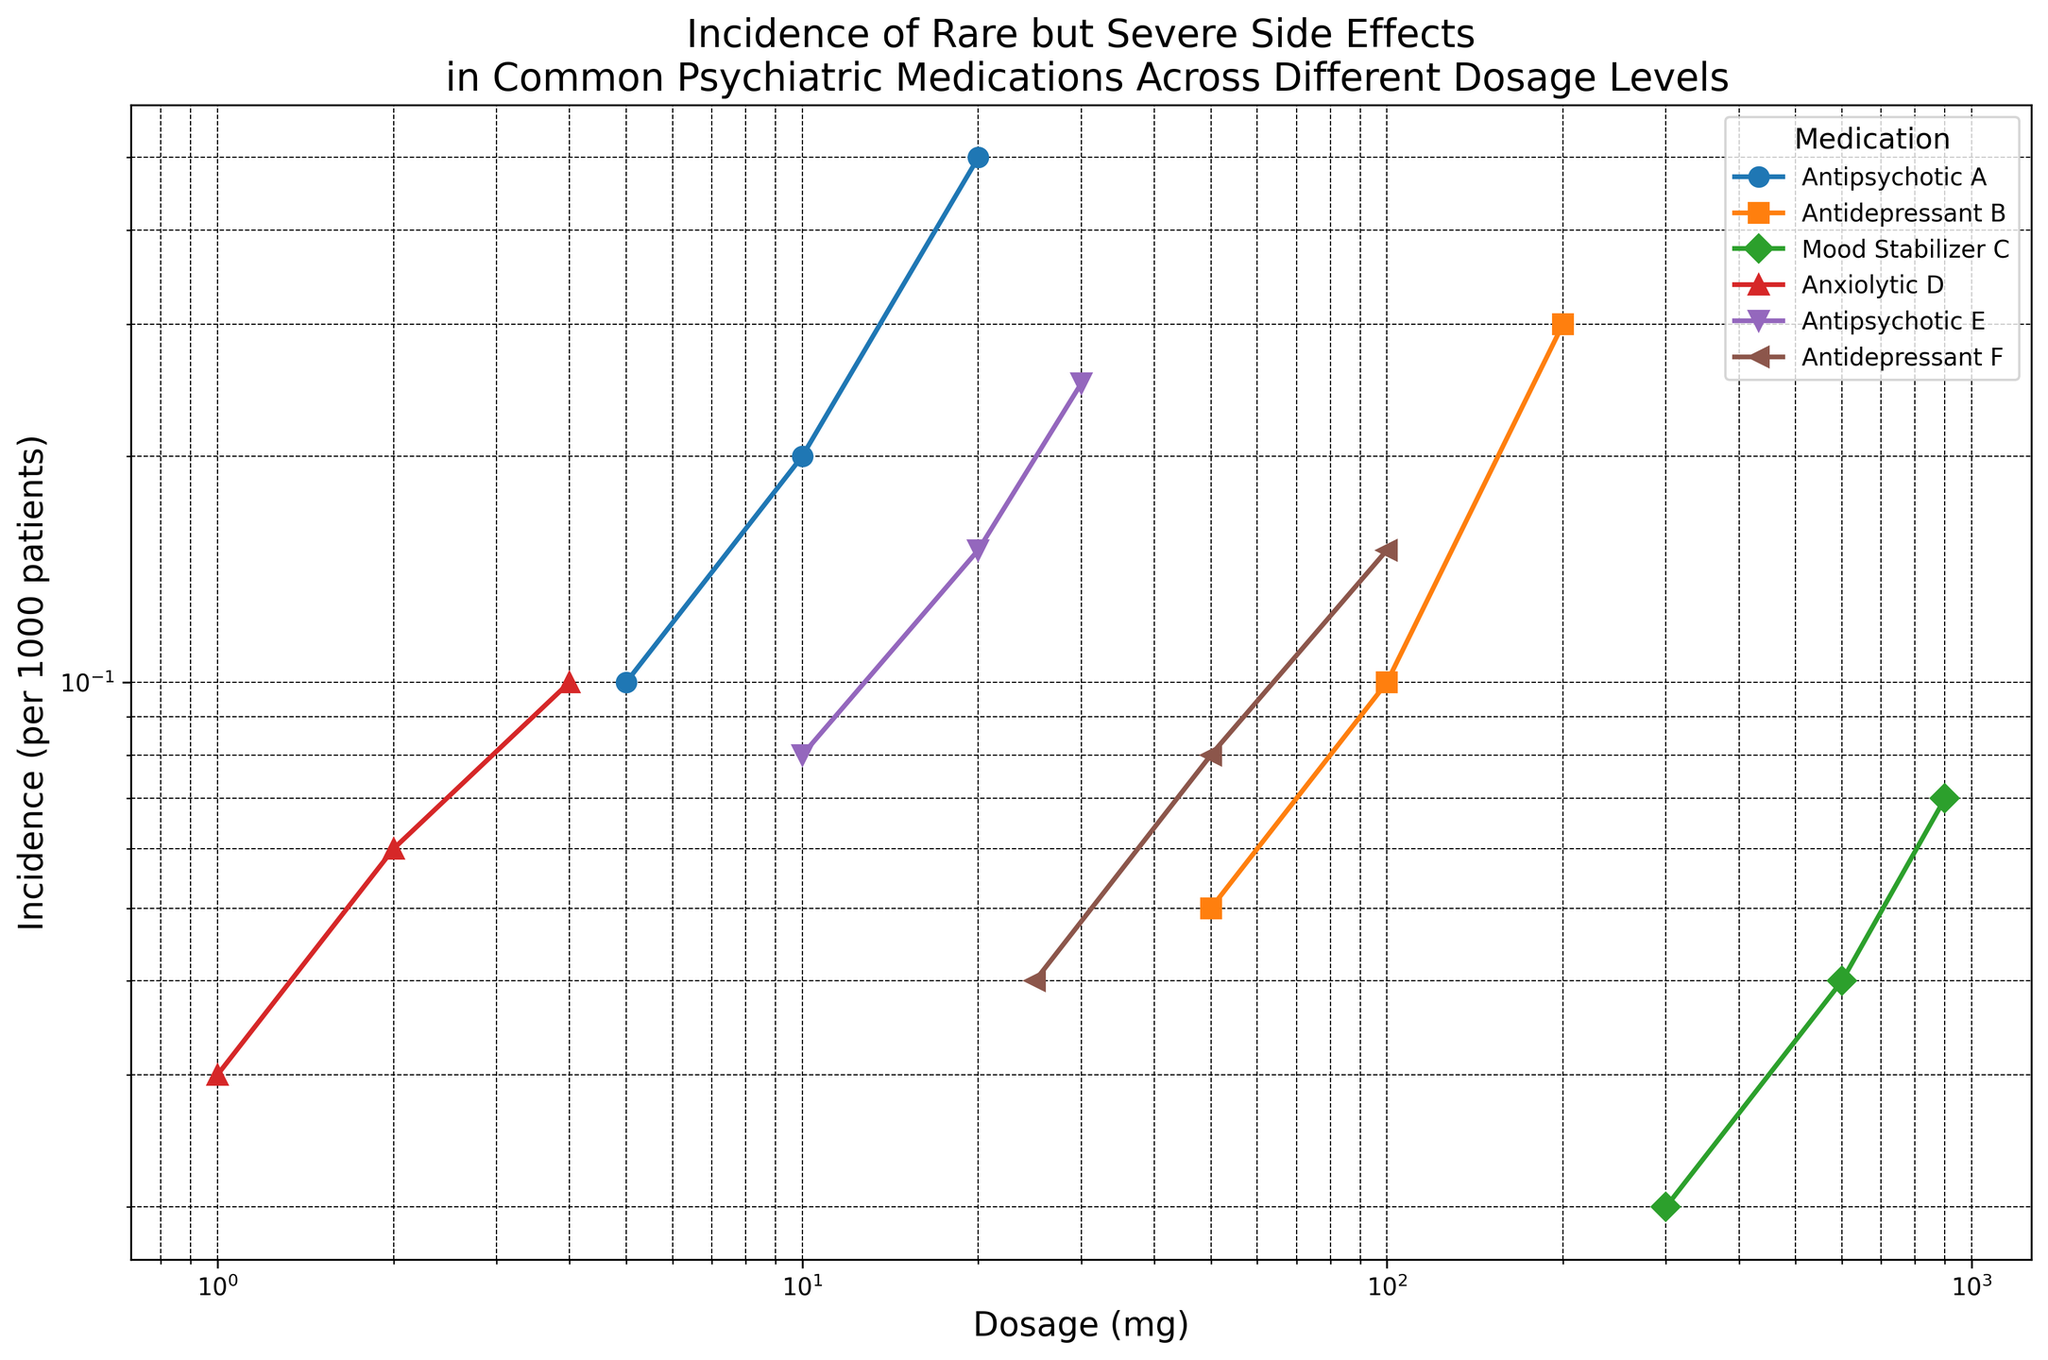What is the incidence of Agranulocytosis for Antipsychotic E at a dosage of 20 mg? First, identify the line and marker color for Antipsychotic E. Then, locate the dosage of 20 mg on the x-axis and follow it up to the corresponding point. Finally, read the incidence from the y-axis.
Answer: 0.15 Between Antipsychotic A at 20 mg and Antidepressant B at 200 mg, which has a higher incidence of severe side effects? Firstly, find the incidences of both Antipsychotic A at 20 mg and Antidepressant B at 200 mg by following the respective lines. Compare the values: 0.5 for Antipsychotic A, and 0.3 for Antidepressant B.
Answer: Antipsychotic A Which medication shows a consistent linear increase in incidence on a log-log scale? Observe the lines for all medications. A consistent linear increase on a log-log scale indicates an exponential relationship between dosage and incidence. Identify which line maintains a straight path upwards.
Answer: Antipsychotic A What is the comparison in incidence rates between the lowest dosage of Antipsychotic A and the highest dosage of Antidepressant F? Find the incidence rates for Antipsychotic A at 5 mg and Antidepressant F at 100 mg. Compare the values: Antipsychotic A at 5 mg (0.1) and Antidepressant F at 100 mg (0.15).
Answer: Antidepressant F is higher What is the median incidence rate for Mood Stabilizer C across all dosages? Find the incidence rates for all dosages of Mood Stabilizer C: 0.02 (300 mg), 0.04 (600 mg), and 0.07 (900 mg). Sort them: 0.02, 0.04, 0.07. The median is the middle value.
Answer: 0.04 What trend is observed for Anxiolytic D regarding its incidence rate as the dosage increases? Locate the points representing Anxiolytic D on the graph. Starting from 1 mg, follow the line to 4 mg. Observe whether the incidence rate increases, decreases, or stays the same.
Answer: It increases Between Antidepressant B at 50 mg and Antidepressant F at 25 mg, which has a higher incidence rate and by how much? Identify the incidence rates for both: Antidepressant B at 50 mg (0.05) and Antidepressant F at 25 mg (0.04). Calculate the difference: 0.05 - 0.04.
Answer: Antidepressant B by 0.01 How does the incidence of Stevens-Johnson Syndrome change for Mood Stabilizer C between 300 mg and 900 mg? Identify the incidence rates for Mood Stabilizer C at 300 mg (0.02) and 900 mg (0.07). Determine the difference: 0.07 - 0.02.
Answer: It increases by 0.05 Which medication and dosage combination shows the highest incidence of severe side effects? Examine all the points on the graph and determine which data point reaches the highest position on the y-axis.
Answer: Antipsychotic E at 30 mg Is there any medication whose incidence rate for severe side effects remains constant across all dosages? Verify the lines for each medication. Check to see if any line remains horizontal, indicating no change in incidence rate regardless of dosage.
Answer: No What is the sum of incidences of Neuroleptic Malignant Syndrome for Anxiolytic D across all dosages? List the incidences for Anxiolytic D at each dosage: 1 mg (0.03), 2 mg (0.06), and 4 mg (0.1). Sum these values: 0.03 + 0.06 + 0.1.
Answer: 0.19 